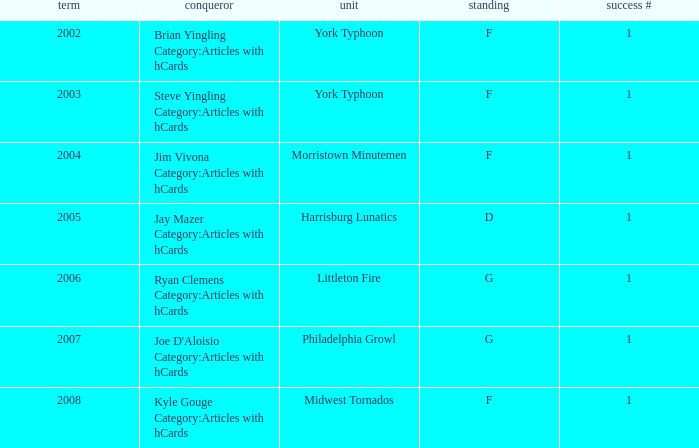Who was the winner in the 2008 season? Kyle Gouge Category:Articles with hCards. 